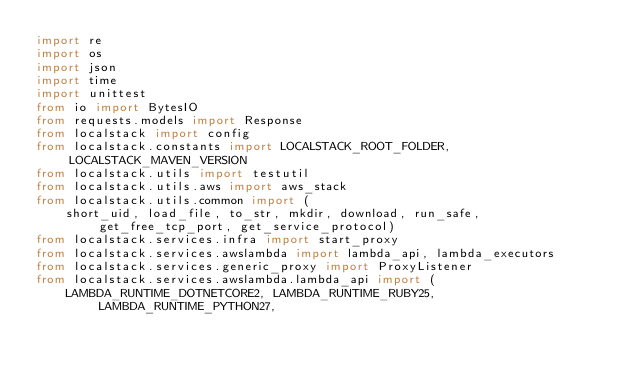<code> <loc_0><loc_0><loc_500><loc_500><_Python_>import re
import os
import json
import time
import unittest
from io import BytesIO
from requests.models import Response
from localstack import config
from localstack.constants import LOCALSTACK_ROOT_FOLDER, LOCALSTACK_MAVEN_VERSION
from localstack.utils import testutil
from localstack.utils.aws import aws_stack
from localstack.utils.common import (
    short_uid, load_file, to_str, mkdir, download, run_safe, get_free_tcp_port, get_service_protocol)
from localstack.services.infra import start_proxy
from localstack.services.awslambda import lambda_api, lambda_executors
from localstack.services.generic_proxy import ProxyListener
from localstack.services.awslambda.lambda_api import (
    LAMBDA_RUNTIME_DOTNETCORE2, LAMBDA_RUNTIME_RUBY25, LAMBDA_RUNTIME_PYTHON27,</code> 